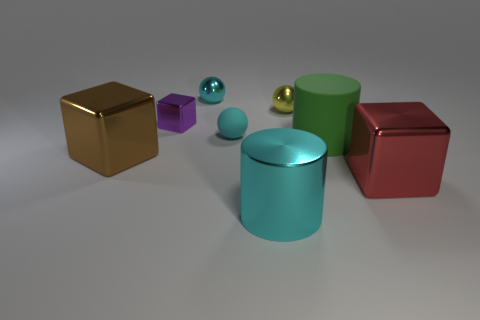Subtract all cyan matte balls. How many balls are left? 2 Add 2 large yellow metal cubes. How many objects exist? 10 Subtract all cyan cylinders. How many cylinders are left? 1 Subtract 2 cyan balls. How many objects are left? 6 Subtract all cubes. How many objects are left? 5 Subtract 2 spheres. How many spheres are left? 1 Subtract all brown spheres. Subtract all blue cylinders. How many spheres are left? 3 Subtract all cyan balls. How many gray cylinders are left? 0 Subtract all brown matte balls. Subtract all rubber balls. How many objects are left? 7 Add 1 brown shiny things. How many brown shiny things are left? 2 